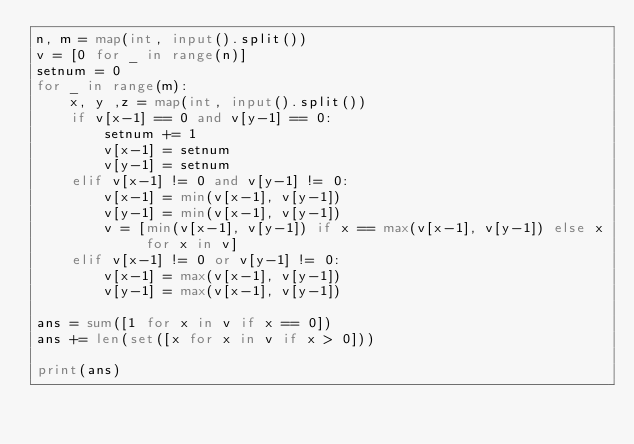Convert code to text. <code><loc_0><loc_0><loc_500><loc_500><_Python_>n, m = map(int, input().split())
v = [0 for _ in range(n)]
setnum = 0
for _ in range(m):
    x, y ,z = map(int, input().split())
    if v[x-1] == 0 and v[y-1] == 0:
        setnum += 1
        v[x-1] = setnum
        v[y-1] = setnum
    elif v[x-1] != 0 and v[y-1] != 0:
        v[x-1] = min(v[x-1], v[y-1])
        v[y-1] = min(v[x-1], v[y-1])
        v = [min(v[x-1], v[y-1]) if x == max(v[x-1], v[y-1]) else x for x in v]
    elif v[x-1] != 0 or v[y-1] != 0:
        v[x-1] = max(v[x-1], v[y-1])
        v[y-1] = max(v[x-1], v[y-1])

ans = sum([1 for x in v if x == 0])
ans += len(set([x for x in v if x > 0]))

print(ans)
</code> 